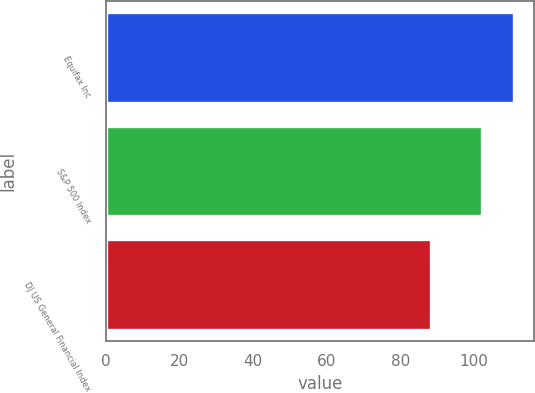<chart> <loc_0><loc_0><loc_500><loc_500><bar_chart><fcel>Equifax Inc<fcel>S&P 500 Index<fcel>DJ US General Financial Index<nl><fcel>110.87<fcel>102.11<fcel>88.38<nl></chart> 